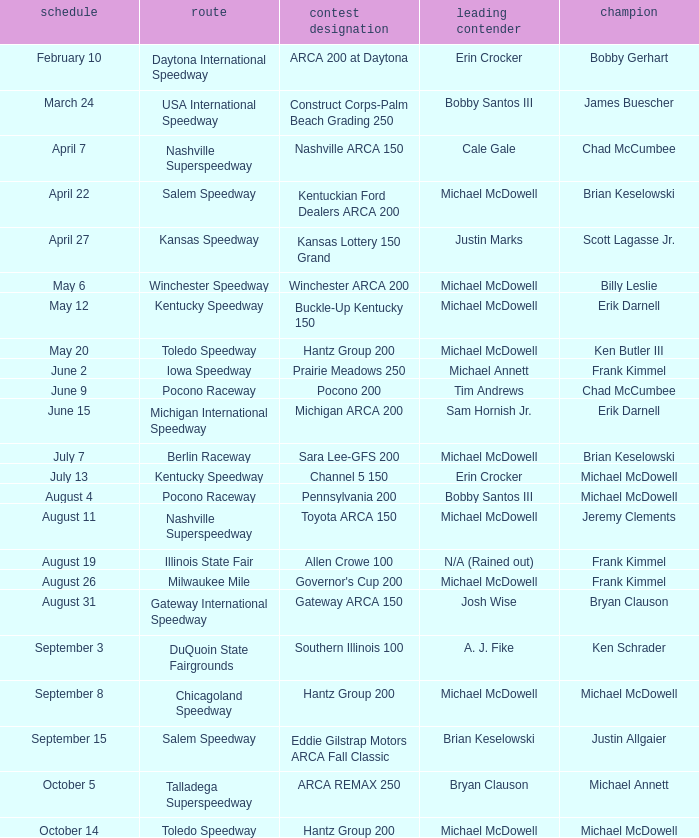Tell me the track for scott lagasse jr. Kansas Speedway. 